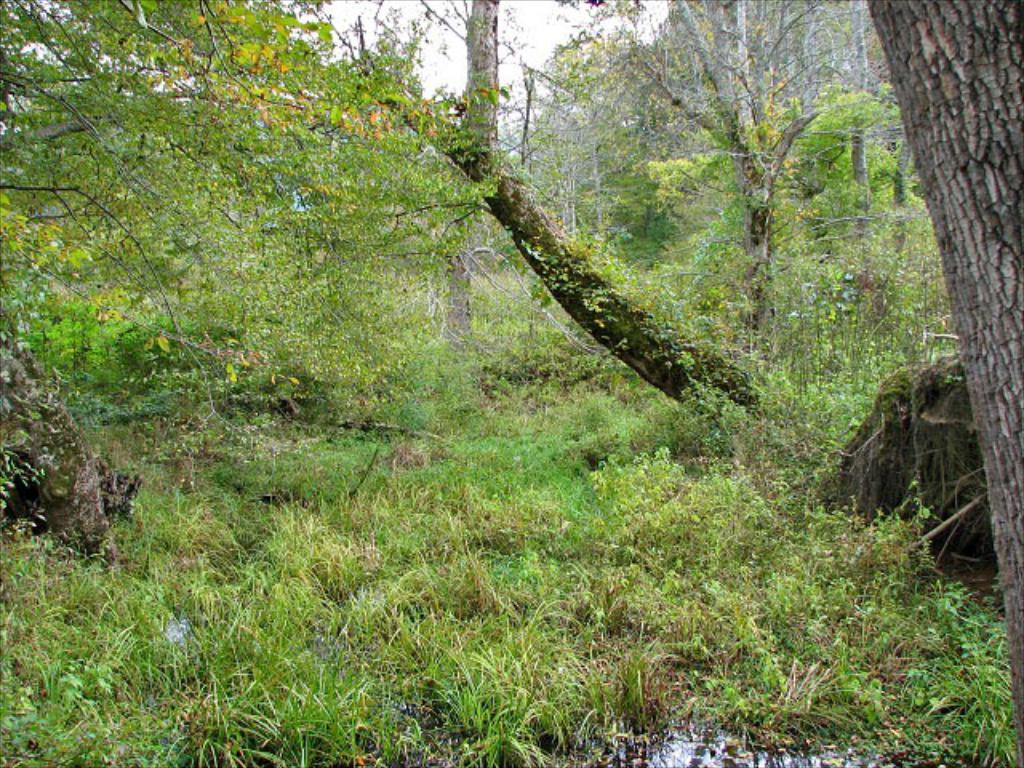What type of vegetation is present in the image? There are trees in the image. What type of ground cover is visible at the bottom of the image? There is grass at the bottom of the image. What part of the natural environment is visible in the background of the image? The sky is visible in the background of the image. How many nerves can be seen in the image? There are no nerves present in the image; it features trees, grass, and the sky. Are there any brothers depicted in the image? There is no reference to any brothers in the image. 